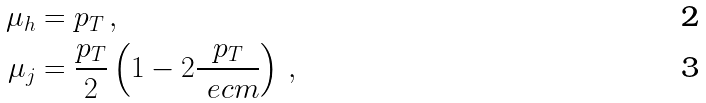Convert formula to latex. <formula><loc_0><loc_0><loc_500><loc_500>\mu _ { h } & = p _ { T } \, , \\ \mu _ { j } & = \frac { p _ { T } } { 2 } \left ( 1 - 2 \frac { p _ { T } } { \ e c m } \right ) \, ,</formula> 